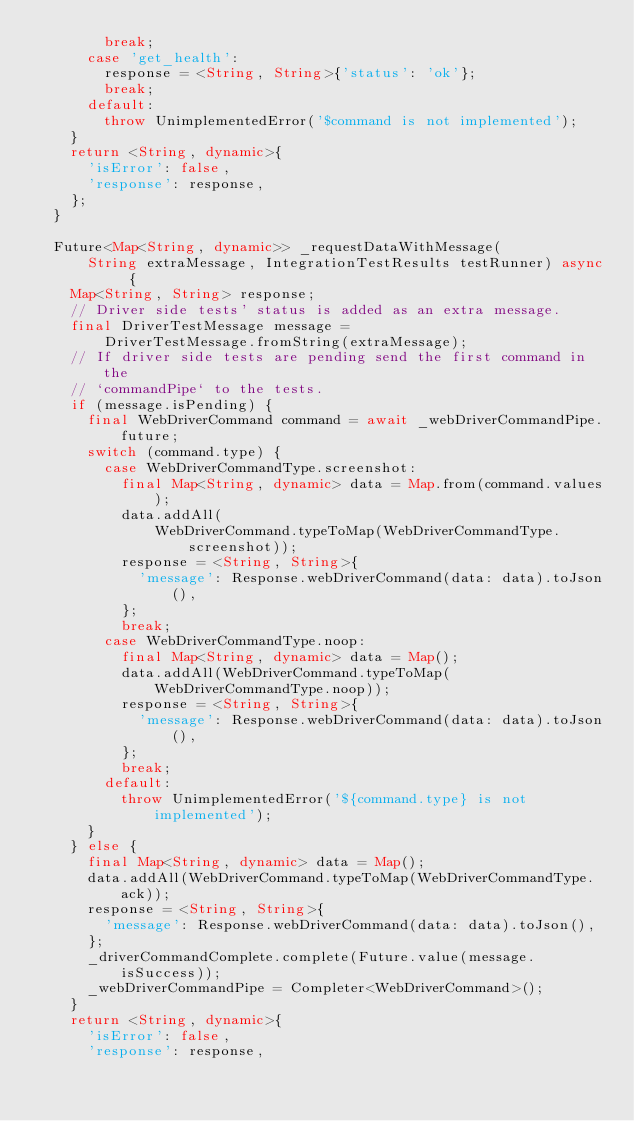<code> <loc_0><loc_0><loc_500><loc_500><_Dart_>        break;
      case 'get_health':
        response = <String, String>{'status': 'ok'};
        break;
      default:
        throw UnimplementedError('$command is not implemented');
    }
    return <String, dynamic>{
      'isError': false,
      'response': response,
    };
  }

  Future<Map<String, dynamic>> _requestDataWithMessage(
      String extraMessage, IntegrationTestResults testRunner) async {
    Map<String, String> response;
    // Driver side tests' status is added as an extra message.
    final DriverTestMessage message =
        DriverTestMessage.fromString(extraMessage);
    // If driver side tests are pending send the first command in the
    // `commandPipe` to the tests.
    if (message.isPending) {
      final WebDriverCommand command = await _webDriverCommandPipe.future;
      switch (command.type) {
        case WebDriverCommandType.screenshot:
          final Map<String, dynamic> data = Map.from(command.values);
          data.addAll(
              WebDriverCommand.typeToMap(WebDriverCommandType.screenshot));
          response = <String, String>{
            'message': Response.webDriverCommand(data: data).toJson(),
          };
          break;
        case WebDriverCommandType.noop:
          final Map<String, dynamic> data = Map();
          data.addAll(WebDriverCommand.typeToMap(WebDriverCommandType.noop));
          response = <String, String>{
            'message': Response.webDriverCommand(data: data).toJson(),
          };
          break;
        default:
          throw UnimplementedError('${command.type} is not implemented');
      }
    } else {
      final Map<String, dynamic> data = Map();
      data.addAll(WebDriverCommand.typeToMap(WebDriverCommandType.ack));
      response = <String, String>{
        'message': Response.webDriverCommand(data: data).toJson(),
      };
      _driverCommandComplete.complete(Future.value(message.isSuccess));
      _webDriverCommandPipe = Completer<WebDriverCommand>();
    }
    return <String, dynamic>{
      'isError': false,
      'response': response,</code> 